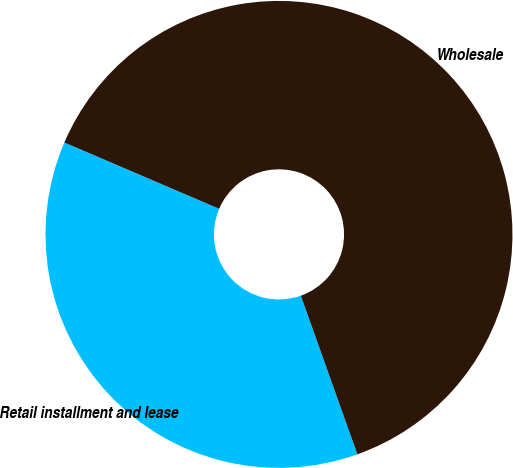<chart> <loc_0><loc_0><loc_500><loc_500><pie_chart><fcel>Retail installment and lease<fcel>Wholesale<nl><fcel>36.89%<fcel>63.11%<nl></chart> 